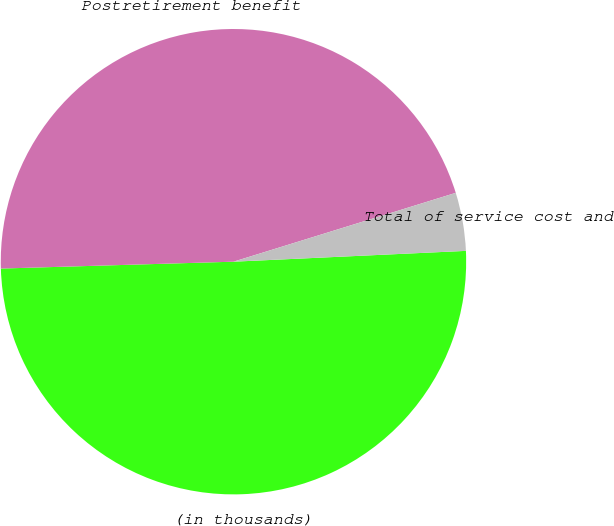Convert chart. <chart><loc_0><loc_0><loc_500><loc_500><pie_chart><fcel>(in thousands)<fcel>Postretirement benefit<fcel>Total of service cost and<nl><fcel>50.27%<fcel>45.69%<fcel>4.04%<nl></chart> 